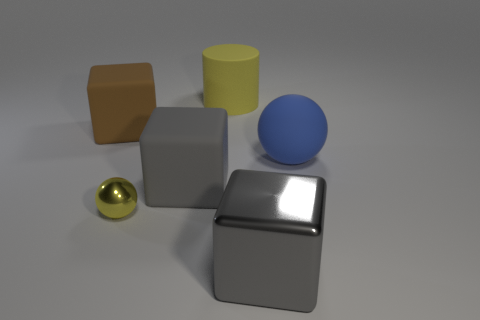What number of purple objects are big metal objects or large cubes?
Provide a short and direct response. 0. Are there fewer yellow rubber cylinders that are on the right side of the yellow matte thing than large blue shiny spheres?
Provide a succinct answer. No. There is a large matte thing that is left of the yellow metallic object; what number of large metallic cubes are on the left side of it?
Give a very brief answer. 0. How many other things are there of the same size as the yellow metal thing?
Keep it short and to the point. 0. How many objects are small green matte cylinders or large rubber objects that are left of the rubber cylinder?
Your answer should be very brief. 2. Is the number of small green rubber objects less than the number of blue matte spheres?
Make the answer very short. Yes. What is the color of the shiny object that is behind the big thing that is in front of the small yellow ball?
Your answer should be compact. Yellow. What is the material of the brown object that is the same shape as the gray matte object?
Offer a terse response. Rubber. What number of matte objects are large blue things or gray cubes?
Your response must be concise. 2. Is the big cube on the right side of the big yellow matte object made of the same material as the large thing that is behind the large brown matte thing?
Keep it short and to the point. No. 